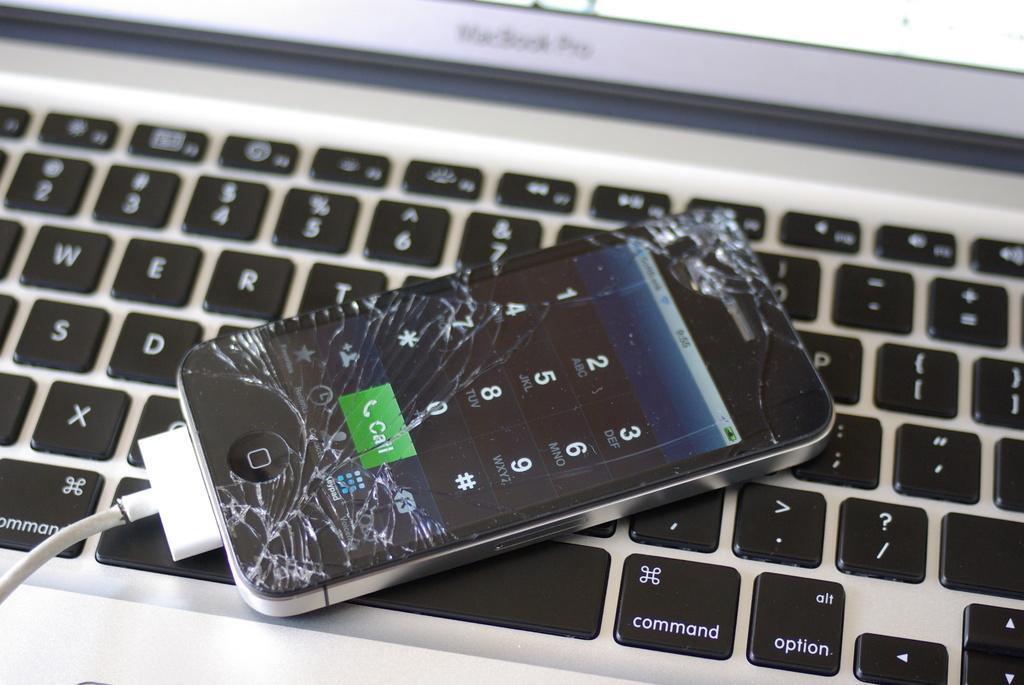<image>
Relay a brief, clear account of the picture shown. A cell phone with a broken screen and the call button lit up sits on a keyboard. 